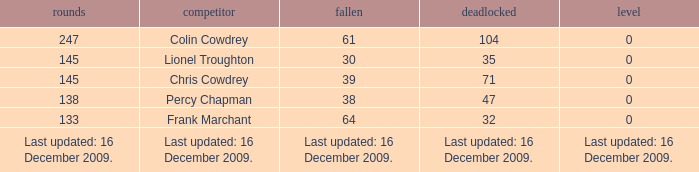I want to know the drawn that has a tie of 0 and the player is chris cowdrey 71.0. 